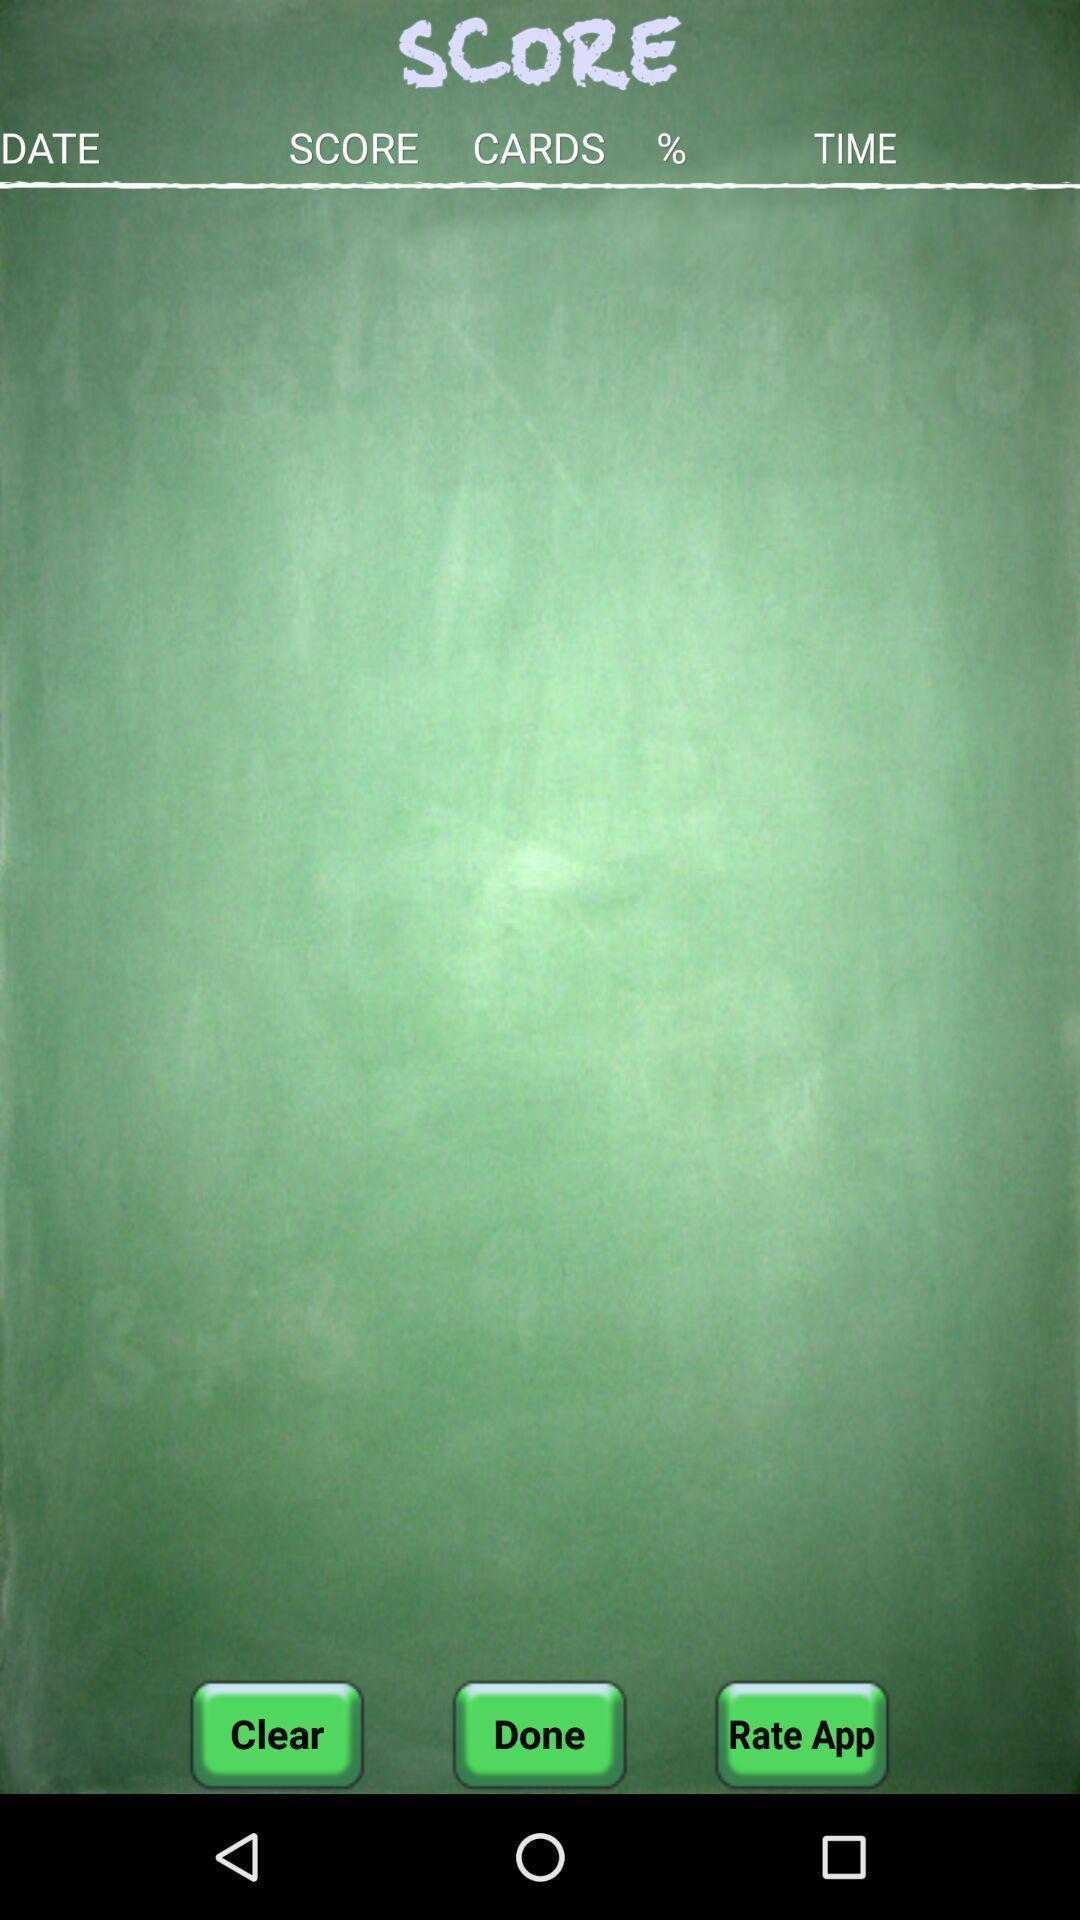Explain what's happening in this screen capture. Screen shows score options in a learning app. 